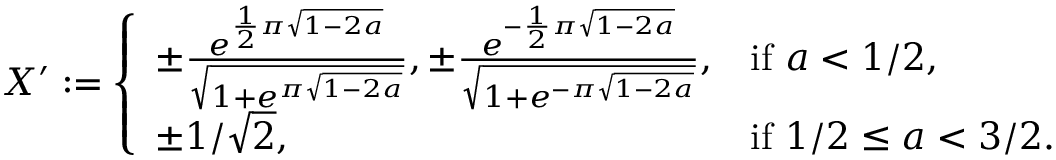Convert formula to latex. <formula><loc_0><loc_0><loc_500><loc_500>\begin{array} { r } { X ^ { \prime } \colon = \left \{ \begin{array} { l l } { \pm \frac { e ^ { \frac { 1 } { 2 } \pi \sqrt { 1 - 2 a } } } { \sqrt { 1 + e ^ { \pi \sqrt { 1 - 2 a } } } } , \pm \frac { e ^ { - \frac { 1 } { 2 } \pi \sqrt { 1 - 2 a } } } { \sqrt { 1 + e ^ { - \pi \sqrt { 1 - 2 a } } } } , } & { i f a < 1 / 2 , } \\ { \pm 1 / \sqrt { 2 } , } & { i f 1 / 2 \leq a < 3 / 2 . } \end{array} } \end{array}</formula> 